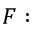Convert formula to latex. <formula><loc_0><loc_0><loc_500><loc_500>F \colon</formula> 